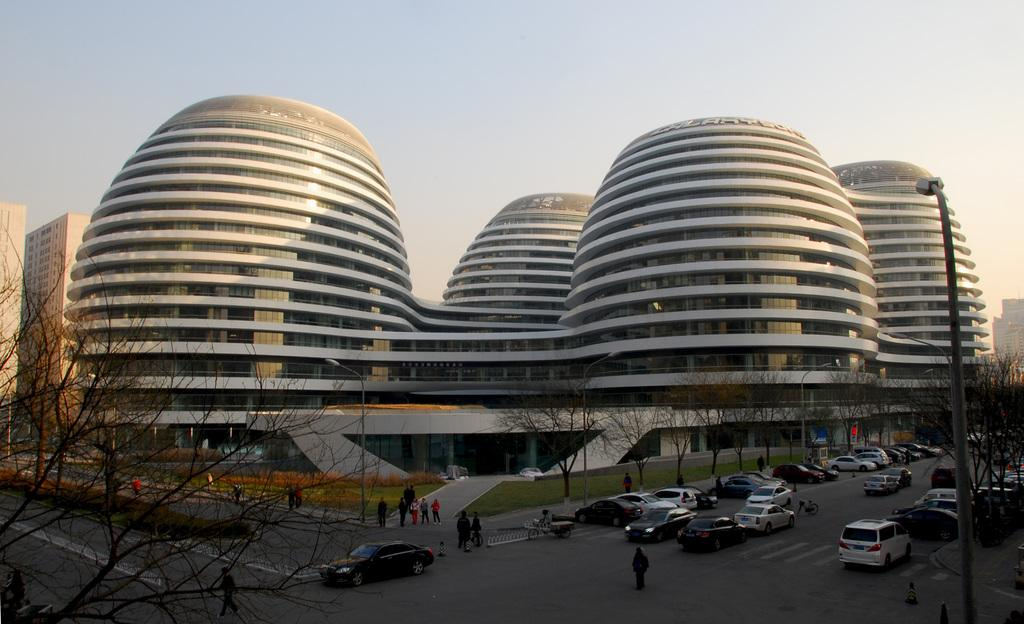What type of natural elements can be seen in the image? There are trees in the image. What man-made structures are present in the image? There are poles and buildings in the image. What type of transportation is visible in the image? There are vehicles in the image. Can you describe the group of people in the image? There is a group of people in the image. What type of seed is being planted by the group of people in the image? There is no seed or planting activity depicted in the image. What is the tendency of the basin in the image? There is no basin present in the image. 